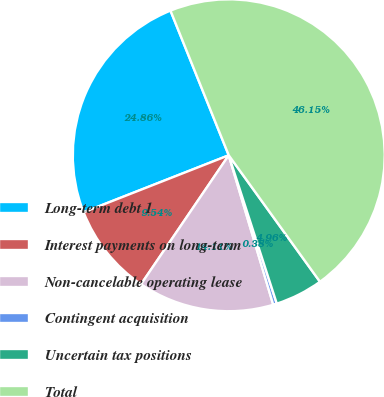<chart> <loc_0><loc_0><loc_500><loc_500><pie_chart><fcel>Long-term debt 1<fcel>Interest payments on long-term<fcel>Non-cancelable operating lease<fcel>Contingent acquisition<fcel>Uncertain tax positions<fcel>Total<nl><fcel>24.86%<fcel>9.54%<fcel>14.11%<fcel>0.38%<fcel>4.96%<fcel>46.15%<nl></chart> 